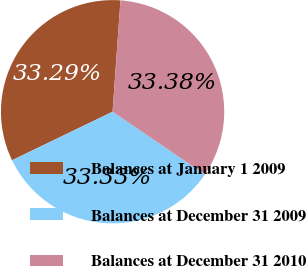Convert chart to OTSL. <chart><loc_0><loc_0><loc_500><loc_500><pie_chart><fcel>Balances at January 1 2009<fcel>Balances at December 31 2009<fcel>Balances at December 31 2010<nl><fcel>33.29%<fcel>33.33%<fcel>33.38%<nl></chart> 